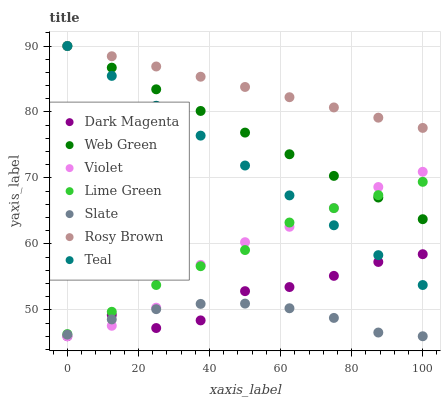Does Slate have the minimum area under the curve?
Answer yes or no. Yes. Does Rosy Brown have the maximum area under the curve?
Answer yes or no. Yes. Does Rosy Brown have the minimum area under the curve?
Answer yes or no. No. Does Slate have the maximum area under the curve?
Answer yes or no. No. Is Web Green the smoothest?
Answer yes or no. Yes. Is Dark Magenta the roughest?
Answer yes or no. Yes. Is Slate the smoothest?
Answer yes or no. No. Is Slate the roughest?
Answer yes or no. No. Does Dark Magenta have the lowest value?
Answer yes or no. Yes. Does Rosy Brown have the lowest value?
Answer yes or no. No. Does Teal have the highest value?
Answer yes or no. Yes. Does Slate have the highest value?
Answer yes or no. No. Is Slate less than Teal?
Answer yes or no. Yes. Is Teal greater than Slate?
Answer yes or no. Yes. Does Lime Green intersect Violet?
Answer yes or no. Yes. Is Lime Green less than Violet?
Answer yes or no. No. Is Lime Green greater than Violet?
Answer yes or no. No. Does Slate intersect Teal?
Answer yes or no. No. 